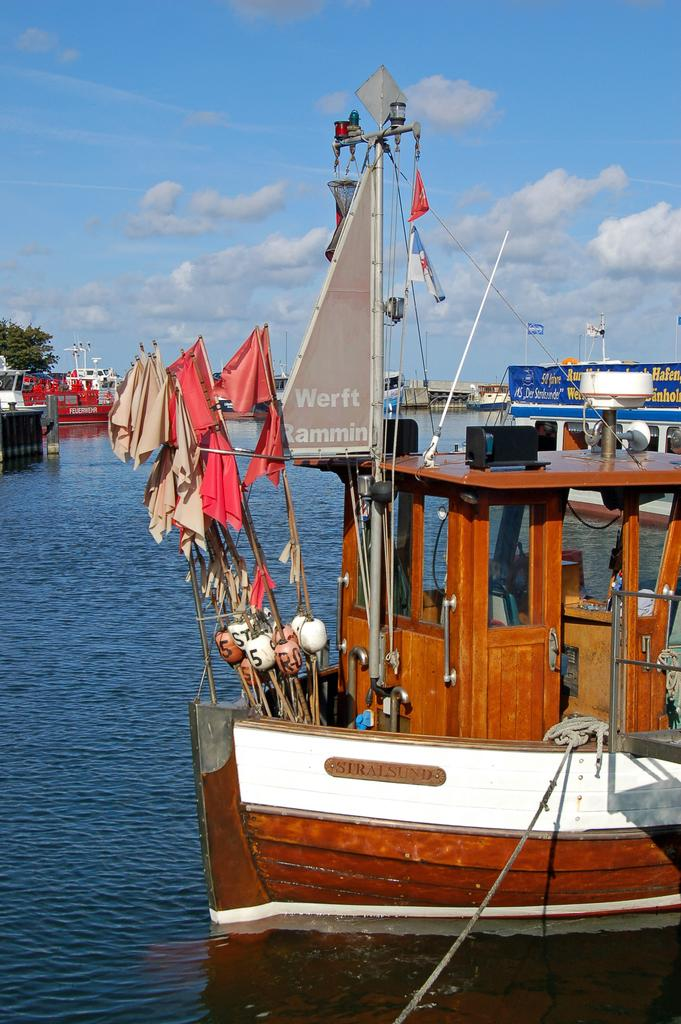<image>
Present a compact description of the photo's key features. a werft sign that is on a boat outside 